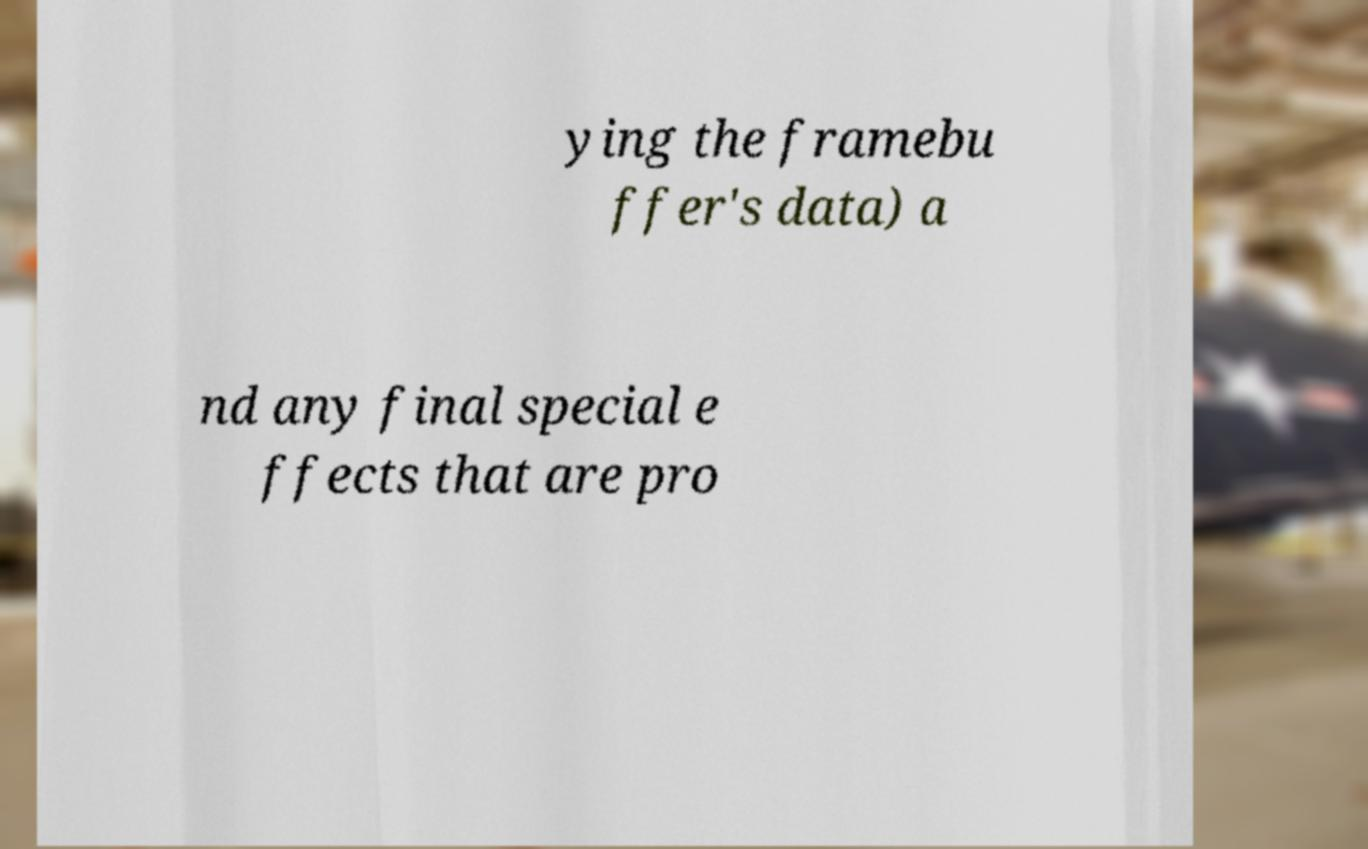I need the written content from this picture converted into text. Can you do that? ying the framebu ffer's data) a nd any final special e ffects that are pro 